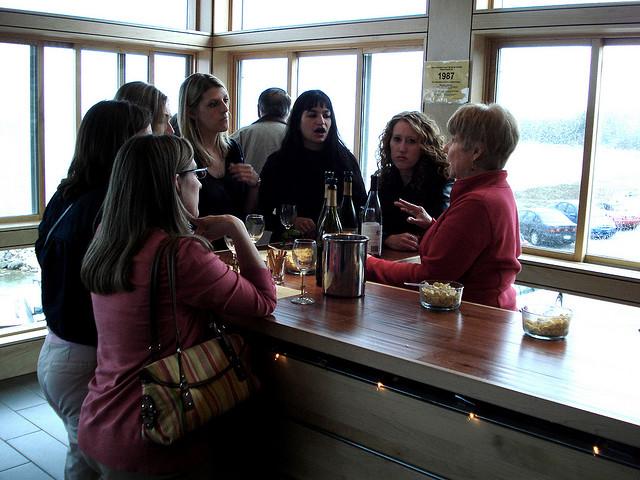What are the ladies doing?
Keep it brief. Talking. Is that a conveyor belt in front of the people?
Short answer required. No. How many people are in the image?
Quick response, please. 8. Is there a man in this group?
Keep it brief. No. Is everyone here over 21?
Be succinct. Yes. 